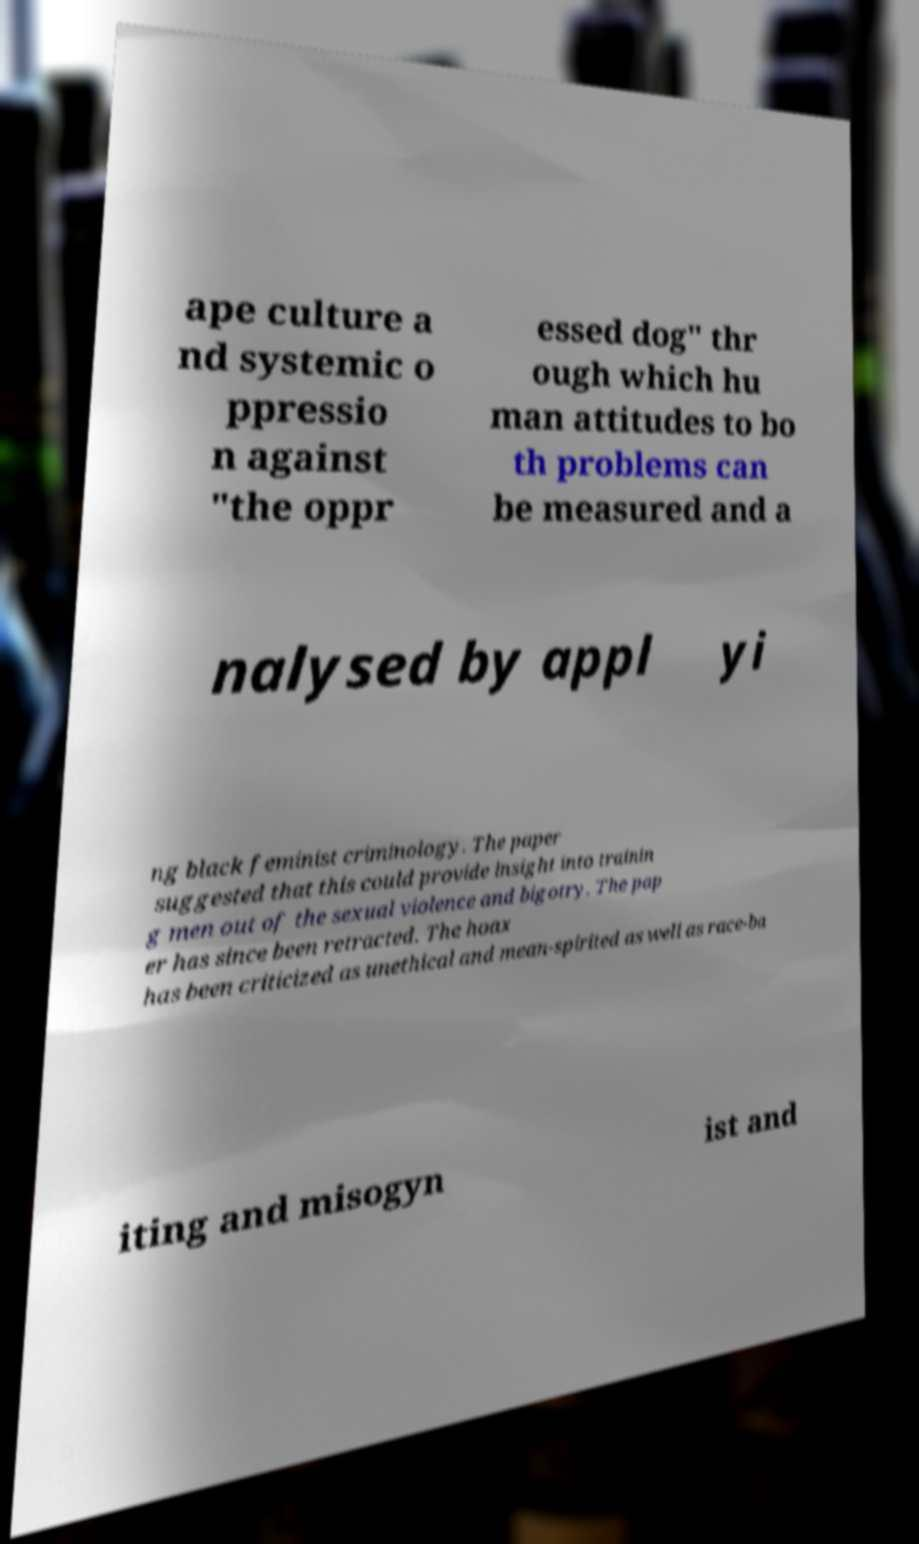Could you extract and type out the text from this image? ape culture a nd systemic o ppressio n against "the oppr essed dog" thr ough which hu man attitudes to bo th problems can be measured and a nalysed by appl yi ng black feminist criminology. The paper suggested that this could provide insight into trainin g men out of the sexual violence and bigotry. The pap er has since been retracted. The hoax has been criticized as unethical and mean-spirited as well as race-ba iting and misogyn ist and 